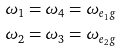Convert formula to latex. <formula><loc_0><loc_0><loc_500><loc_500>\omega _ { 1 } & = \omega _ { 4 } = \omega _ { e _ { 1 } g } \\ \omega _ { 2 } & = \omega _ { 3 } = \omega _ { e _ { 2 } g }</formula> 